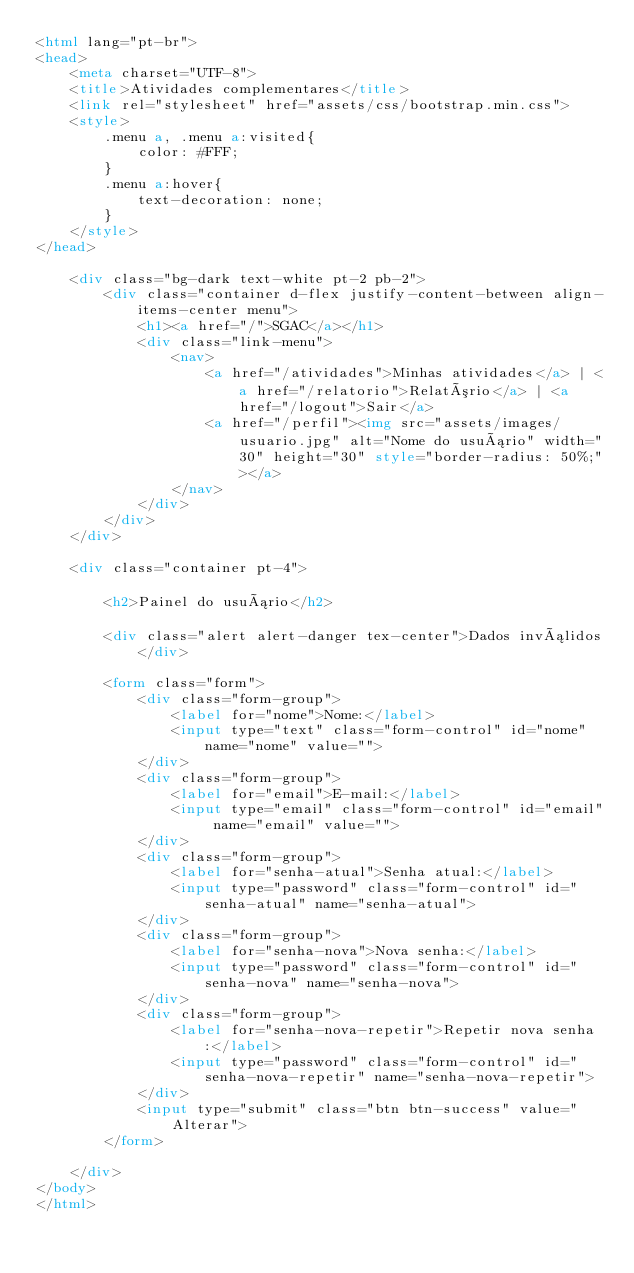<code> <loc_0><loc_0><loc_500><loc_500><_HTML_><html lang="pt-br">
<head>
    <meta charset="UTF-8">
    <title>Atividades complementares</title>
    <link rel="stylesheet" href="assets/css/bootstrap.min.css">
    <style>
        .menu a, .menu a:visited{
            color: #FFF;
        }
        .menu a:hover{
            text-decoration: none;
        }
    </style>
</head>

    <div class="bg-dark text-white pt-2 pb-2">
        <div class="container d-flex justify-content-between align-items-center menu">
            <h1><a href="/">SGAC</a></h1>
            <div class="link-menu">
                <nav>
                    <a href="/atividades">Minhas atividades</a> | <a href="/relatorio">Relatório</a> | <a href="/logout">Sair</a>
                    <a href="/perfil"><img src="assets/images/usuario.jpg" alt="Nome do usuário" width="30" height="30" style="border-radius: 50%;"></a>
                </nav>
            </div>
        </div>
    </div>

    <div class="container pt-4">

        <h2>Painel do usuário</h2>
        
        <div class="alert alert-danger tex-center">Dados inválidos</div>

        <form class="form">
            <div class="form-group">
                <label for="nome">Nome:</label>
                <input type="text" class="form-control" id="nome" name="nome" value="">
            </div>
            <div class="form-group">
                <label for="email">E-mail:</label>
                <input type="email" class="form-control" id="email" name="email" value="">
            </div>
            <div class="form-group">
                <label for="senha-atual">Senha atual:</label>
                <input type="password" class="form-control" id="senha-atual" name="senha-atual">
            </div>
            <div class="form-group">
                <label for="senha-nova">Nova senha:</label>
                <input type="password" class="form-control" id="senha-nova" name="senha-nova">
            </div>
            <div class="form-group">
                <label for="senha-nova-repetir">Repetir nova senha:</label>
                <input type="password" class="form-control" id="senha-nova-repetir" name="senha-nova-repetir">
            </div>
            <input type="submit" class="btn btn-success" value="Alterar">
        </form>

    </div>
</body>
</html>
</code> 